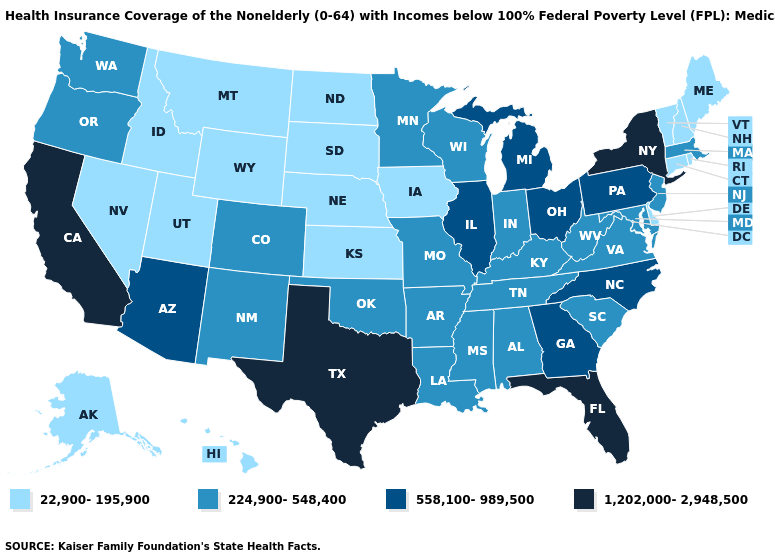What is the highest value in states that border North Carolina?
Quick response, please. 558,100-989,500. Which states hav the highest value in the West?
Quick response, please. California. Which states have the lowest value in the MidWest?
Give a very brief answer. Iowa, Kansas, Nebraska, North Dakota, South Dakota. Name the states that have a value in the range 558,100-989,500?
Keep it brief. Arizona, Georgia, Illinois, Michigan, North Carolina, Ohio, Pennsylvania. How many symbols are there in the legend?
Give a very brief answer. 4. Does Maine have the lowest value in the Northeast?
Give a very brief answer. Yes. Does the first symbol in the legend represent the smallest category?
Give a very brief answer. Yes. Does the first symbol in the legend represent the smallest category?
Be succinct. Yes. Does the map have missing data?
Concise answer only. No. What is the value of Maryland?
Short answer required. 224,900-548,400. What is the highest value in the Northeast ?
Give a very brief answer. 1,202,000-2,948,500. Does the map have missing data?
Give a very brief answer. No. What is the value of Arkansas?
Keep it brief. 224,900-548,400. Name the states that have a value in the range 224,900-548,400?
Write a very short answer. Alabama, Arkansas, Colorado, Indiana, Kentucky, Louisiana, Maryland, Massachusetts, Minnesota, Mississippi, Missouri, New Jersey, New Mexico, Oklahoma, Oregon, South Carolina, Tennessee, Virginia, Washington, West Virginia, Wisconsin. 